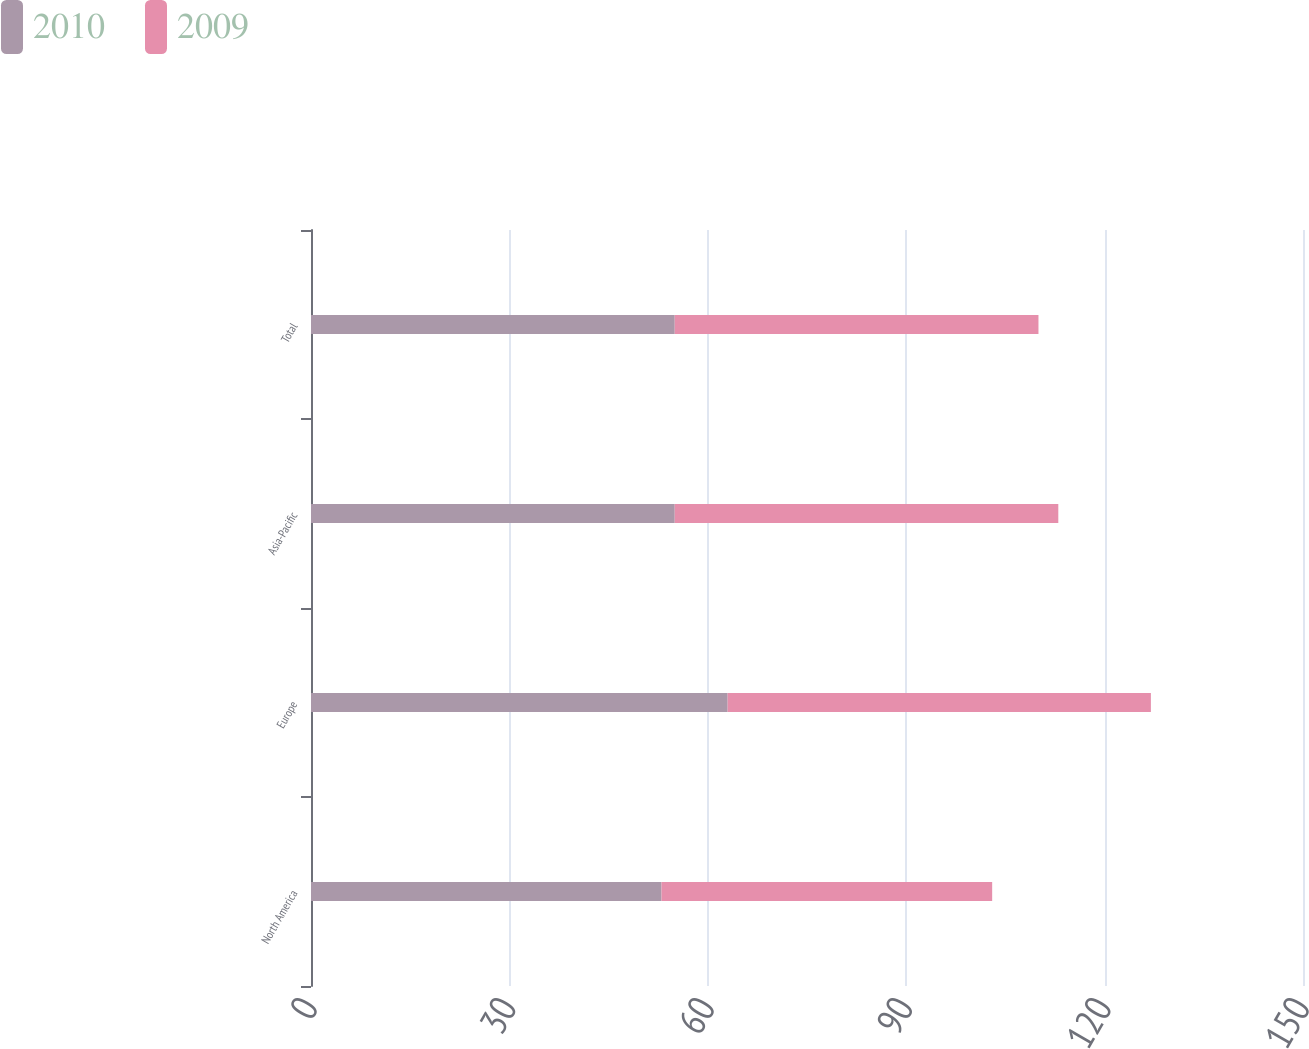Convert chart. <chart><loc_0><loc_0><loc_500><loc_500><stacked_bar_chart><ecel><fcel>North America<fcel>Europe<fcel>Asia-Pacific<fcel>Total<nl><fcel>2010<fcel>53<fcel>63<fcel>55<fcel>55<nl><fcel>2009<fcel>50<fcel>64<fcel>58<fcel>55<nl></chart> 